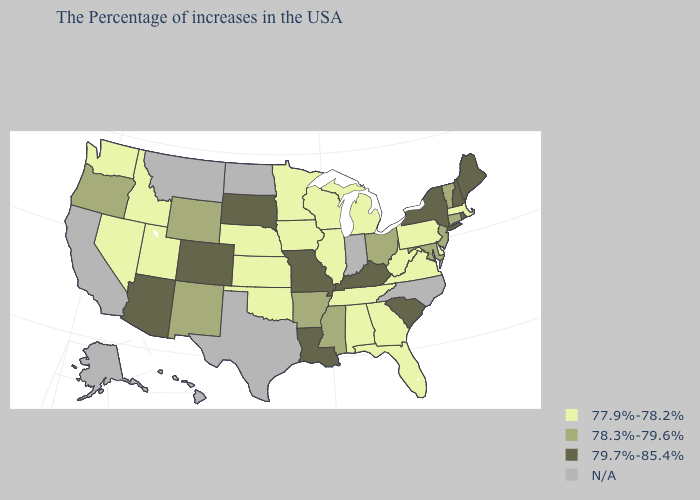What is the lowest value in states that border Michigan?
Quick response, please. 77.9%-78.2%. Name the states that have a value in the range N/A?
Write a very short answer. North Carolina, Indiana, Texas, North Dakota, Montana, California, Alaska, Hawaii. How many symbols are there in the legend?
Concise answer only. 4. What is the highest value in states that border Utah?
Quick response, please. 79.7%-85.4%. What is the value of Oregon?
Keep it brief. 78.3%-79.6%. Among the states that border West Virginia , does Maryland have the highest value?
Short answer required. No. What is the value of North Carolina?
Be succinct. N/A. How many symbols are there in the legend?
Write a very short answer. 4. Which states have the lowest value in the Northeast?
Be succinct. Massachusetts, Pennsylvania. How many symbols are there in the legend?
Give a very brief answer. 4. Does Massachusetts have the lowest value in the Northeast?
Answer briefly. Yes. Name the states that have a value in the range N/A?
Give a very brief answer. North Carolina, Indiana, Texas, North Dakota, Montana, California, Alaska, Hawaii. Which states have the lowest value in the USA?
Quick response, please. Massachusetts, Delaware, Pennsylvania, Virginia, West Virginia, Florida, Georgia, Michigan, Alabama, Tennessee, Wisconsin, Illinois, Minnesota, Iowa, Kansas, Nebraska, Oklahoma, Utah, Idaho, Nevada, Washington. Which states hav the highest value in the MidWest?
Concise answer only. Missouri, South Dakota. 